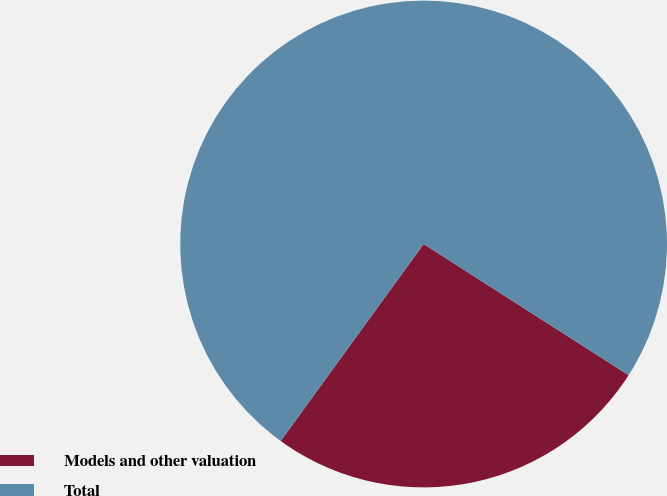Convert chart. <chart><loc_0><loc_0><loc_500><loc_500><pie_chart><fcel>Models and other valuation<fcel>Total<nl><fcel>25.93%<fcel>74.07%<nl></chart> 